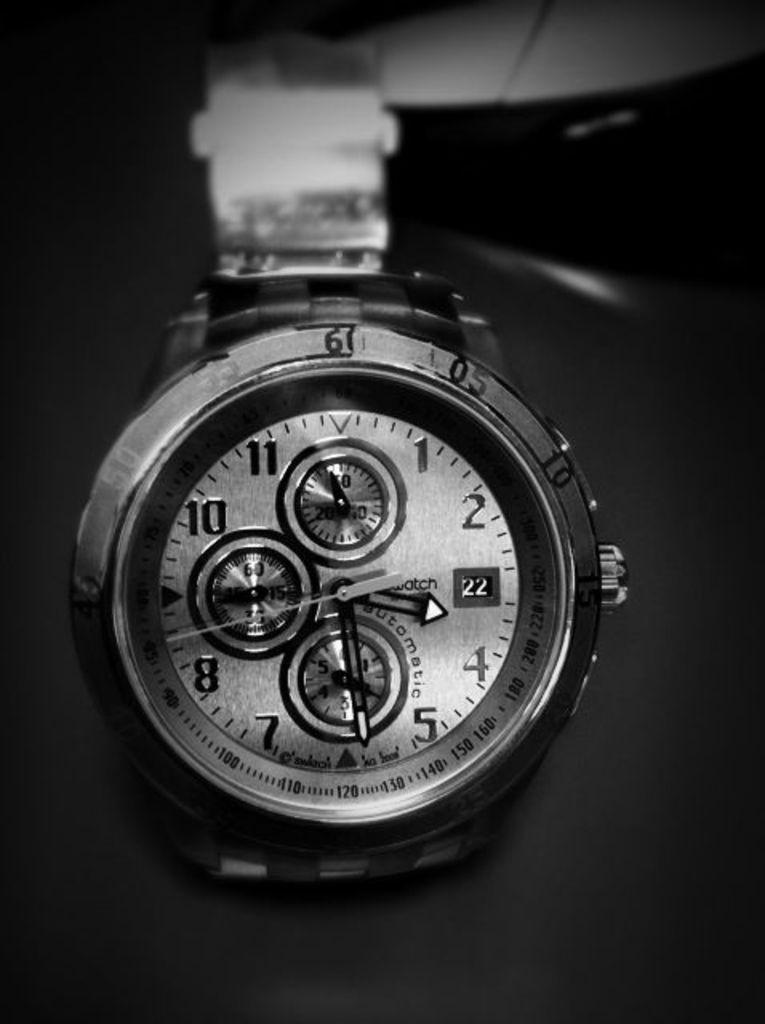Provide a one-sentence caption for the provided image. The steel watch displays a time of 3:29. 